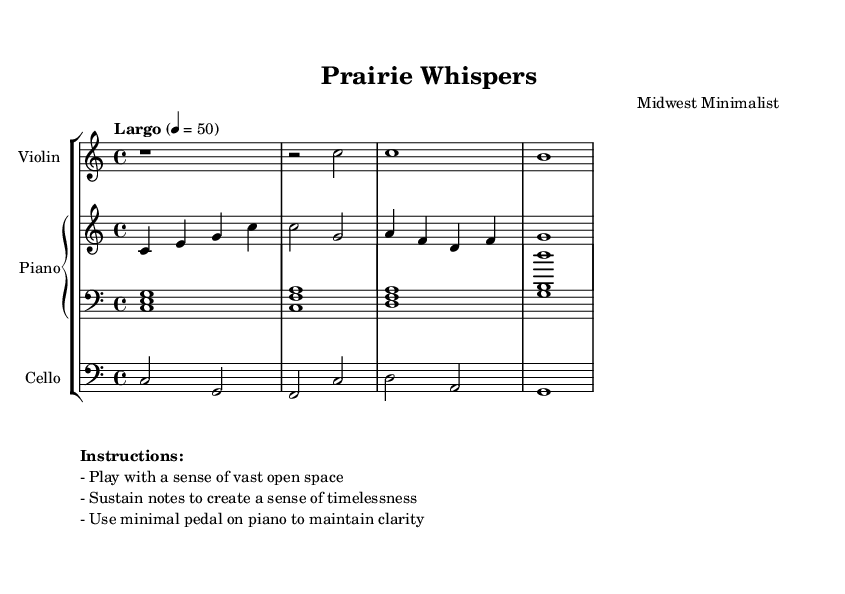What is the title of this composition? The title is prominently displayed in the header section of the sheet music.
Answer: Prairie Whispers What is the key signature of this music? The key signature indicated is C major, which has no sharps or flats.
Answer: C major What is the time signature of this music? The time signature is found at the beginning of the score, showing 4 beats per measure.
Answer: 4/4 What is the tempo marking for this piece? The tempo marking indicates the speed at which the piece should be played; in this case, it is "Largo" with a marking of 50 beats per minute.
Answer: Largo How many measures are in the piano right hand part? Counting the individual measures indicated in the right hand part will show there are a total of four measures.
Answer: 4 What is the overall mood suggested by the performance instructions? The instructions emphasize playing with a sense of vast open space and sustain, indicating a tranquil and immersive mood.
Answer: Timelessness Which instruments are included in this composition? The instruments are listed with their respective staves within the score; they include piano, violin, and cello.
Answer: Piano, Violin, Cello 